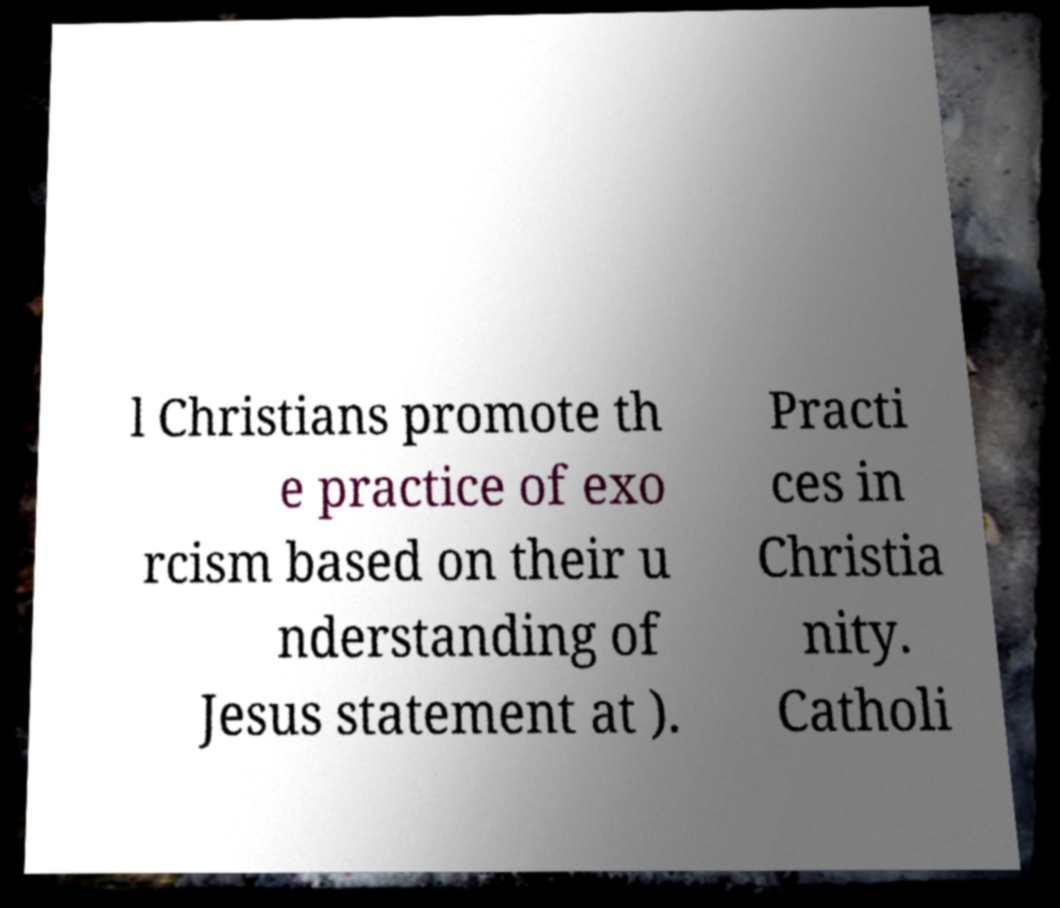For documentation purposes, I need the text within this image transcribed. Could you provide that? l Christians promote th e practice of exo rcism based on their u nderstanding of Jesus statement at ). Practi ces in Christia nity. Catholi 